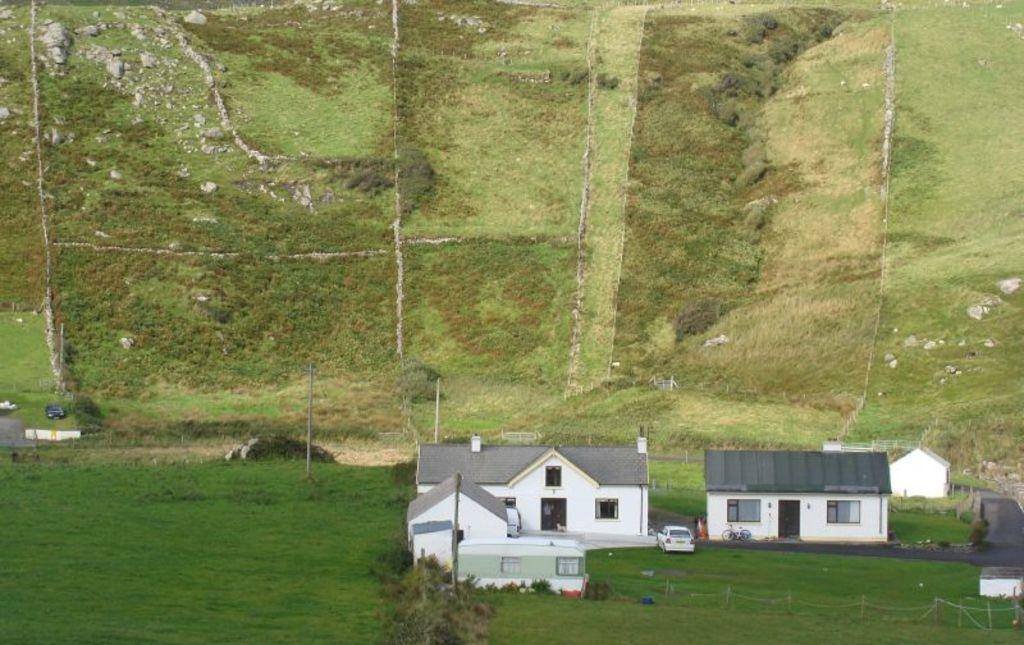What type of structures can be seen in the image? There are houses in the image. What else is present on the ground in the image? There are vehicles on the ground in the image. What can be seen in the background of the image? There are trees, poles, and grass in the background of the image. What type of design can be seen on the rainstorm in the image? There is no rainstorm present in the image, so it is not possible to answer that question. 